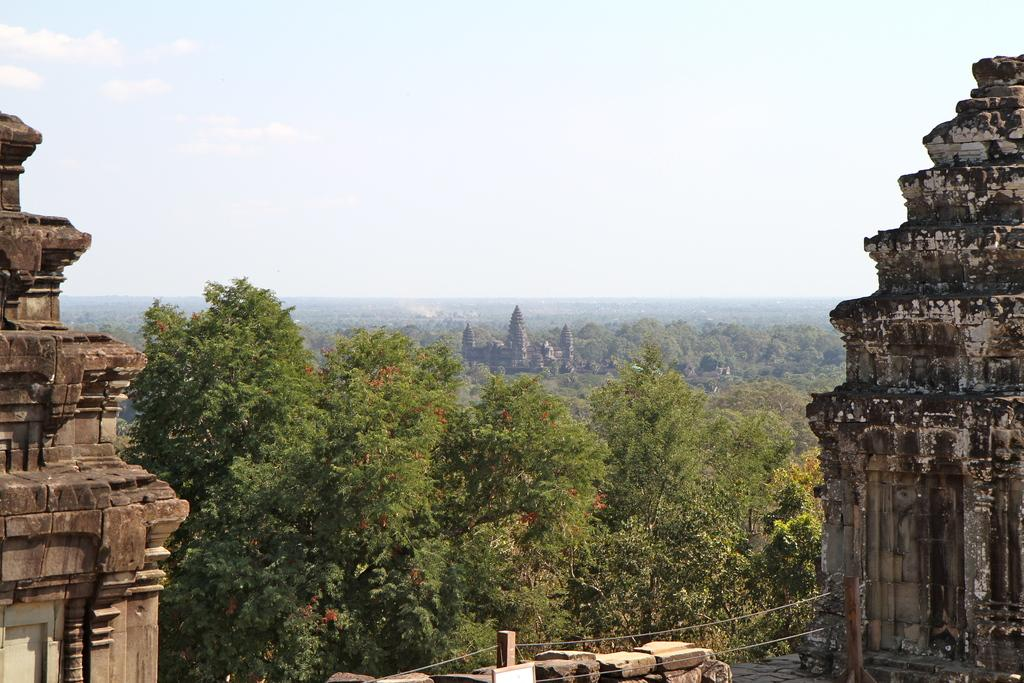What type of structures can be seen in the image? There are buildings in the image. What type of vegetation is present in the image? There are trees with green color in the image. What is the color of the sky in the image? The sky is in white color in the image. How many kittens are playing with butter on the windowsill in the image? There are no kittens or butter present in the image, and there is no windowsill visible. 